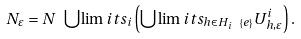<formula> <loc_0><loc_0><loc_500><loc_500>N _ { \varepsilon } = N \ \bigcup \lim i t s _ { i } \left ( \bigcup \lim i t s _ { h \in H _ { i } \ \left \{ e \right \} } U _ { h , \varepsilon } ^ { i } \right ) .</formula> 